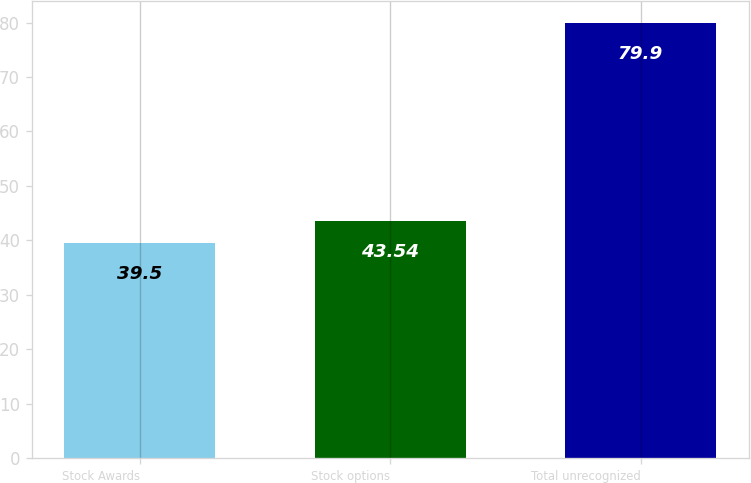Convert chart to OTSL. <chart><loc_0><loc_0><loc_500><loc_500><bar_chart><fcel>Stock Awards<fcel>Stock options<fcel>Total unrecognized<nl><fcel>39.5<fcel>43.54<fcel>79.9<nl></chart> 